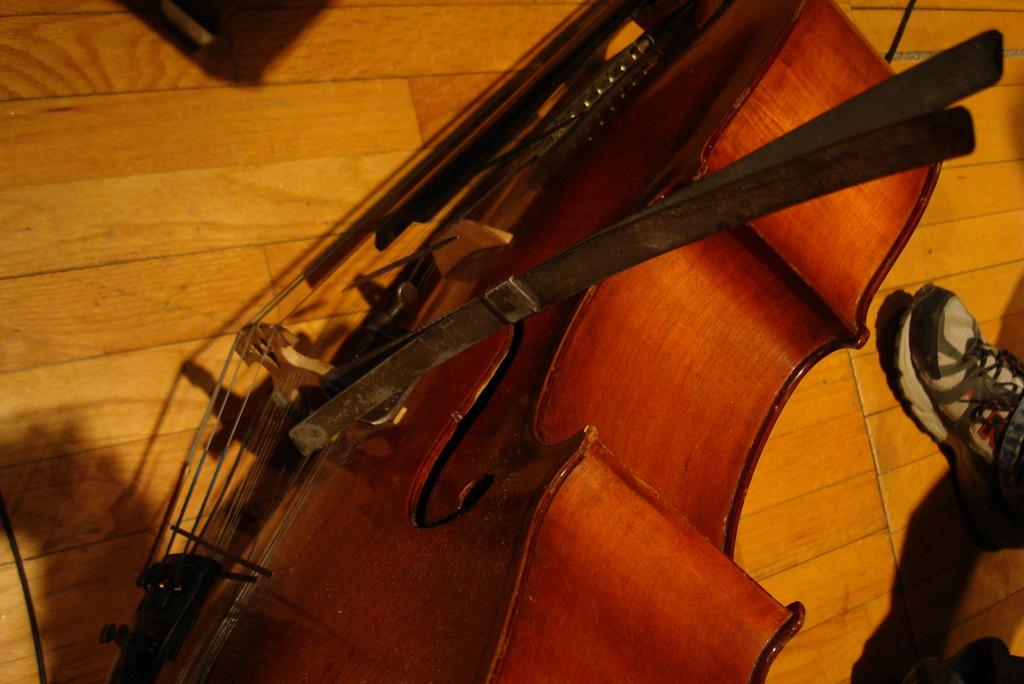What musical instrument is present in the image? There is a cello in the image. Where is the cello located? The cello is placed on the wooden floor. Can you see any part of a person in the image? Yes, there is a foot of a person on the right side of the image. What type of writing can be seen on the cello in the image? There is no writing visible on the cello in the image. Is there a cabbage placed next to the cello in the image? No, there is no cabbage present in the image. 